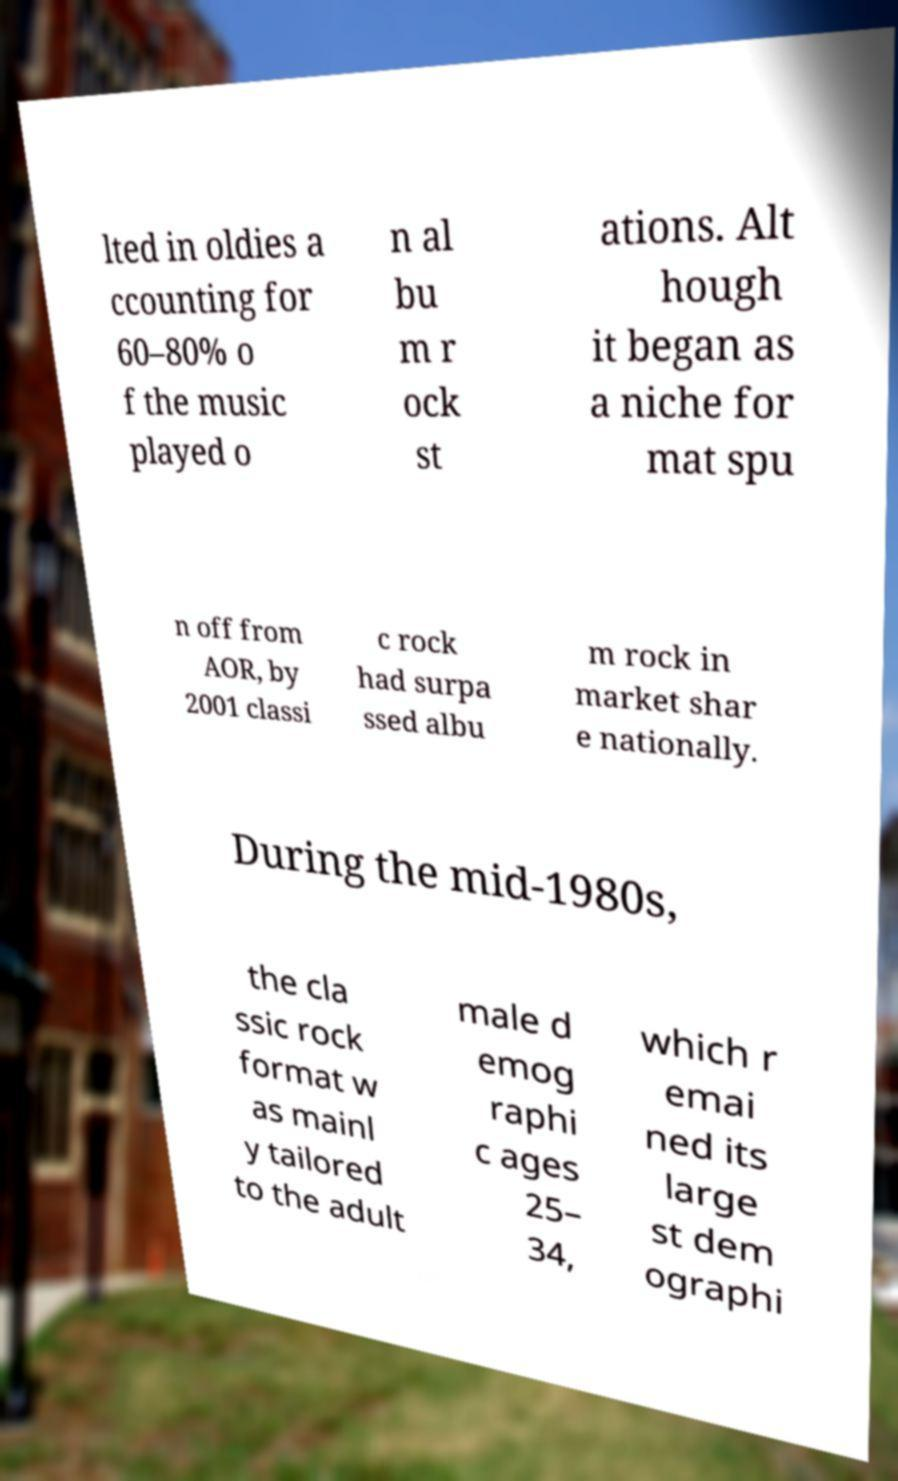What messages or text are displayed in this image? I need them in a readable, typed format. lted in oldies a ccounting for 60–80% o f the music played o n al bu m r ock st ations. Alt hough it began as a niche for mat spu n off from AOR, by 2001 classi c rock had surpa ssed albu m rock in market shar e nationally. During the mid-1980s, the cla ssic rock format w as mainl y tailored to the adult male d emog raphi c ages 25– 34, which r emai ned its large st dem ographi 